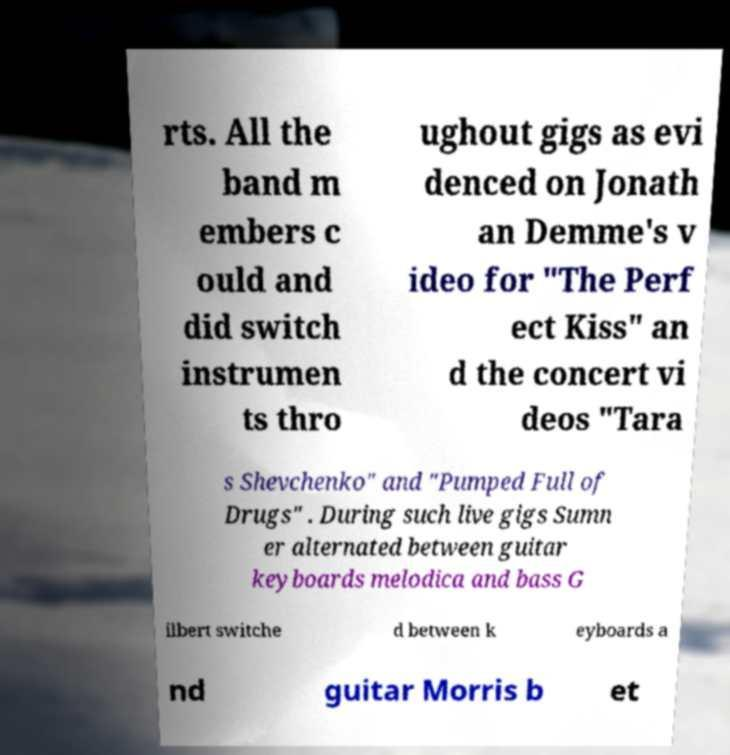There's text embedded in this image that I need extracted. Can you transcribe it verbatim? rts. All the band m embers c ould and did switch instrumen ts thro ughout gigs as evi denced on Jonath an Demme's v ideo for "The Perf ect Kiss" an d the concert vi deos "Tara s Shevchenko" and "Pumped Full of Drugs" . During such live gigs Sumn er alternated between guitar keyboards melodica and bass G ilbert switche d between k eyboards a nd guitar Morris b et 